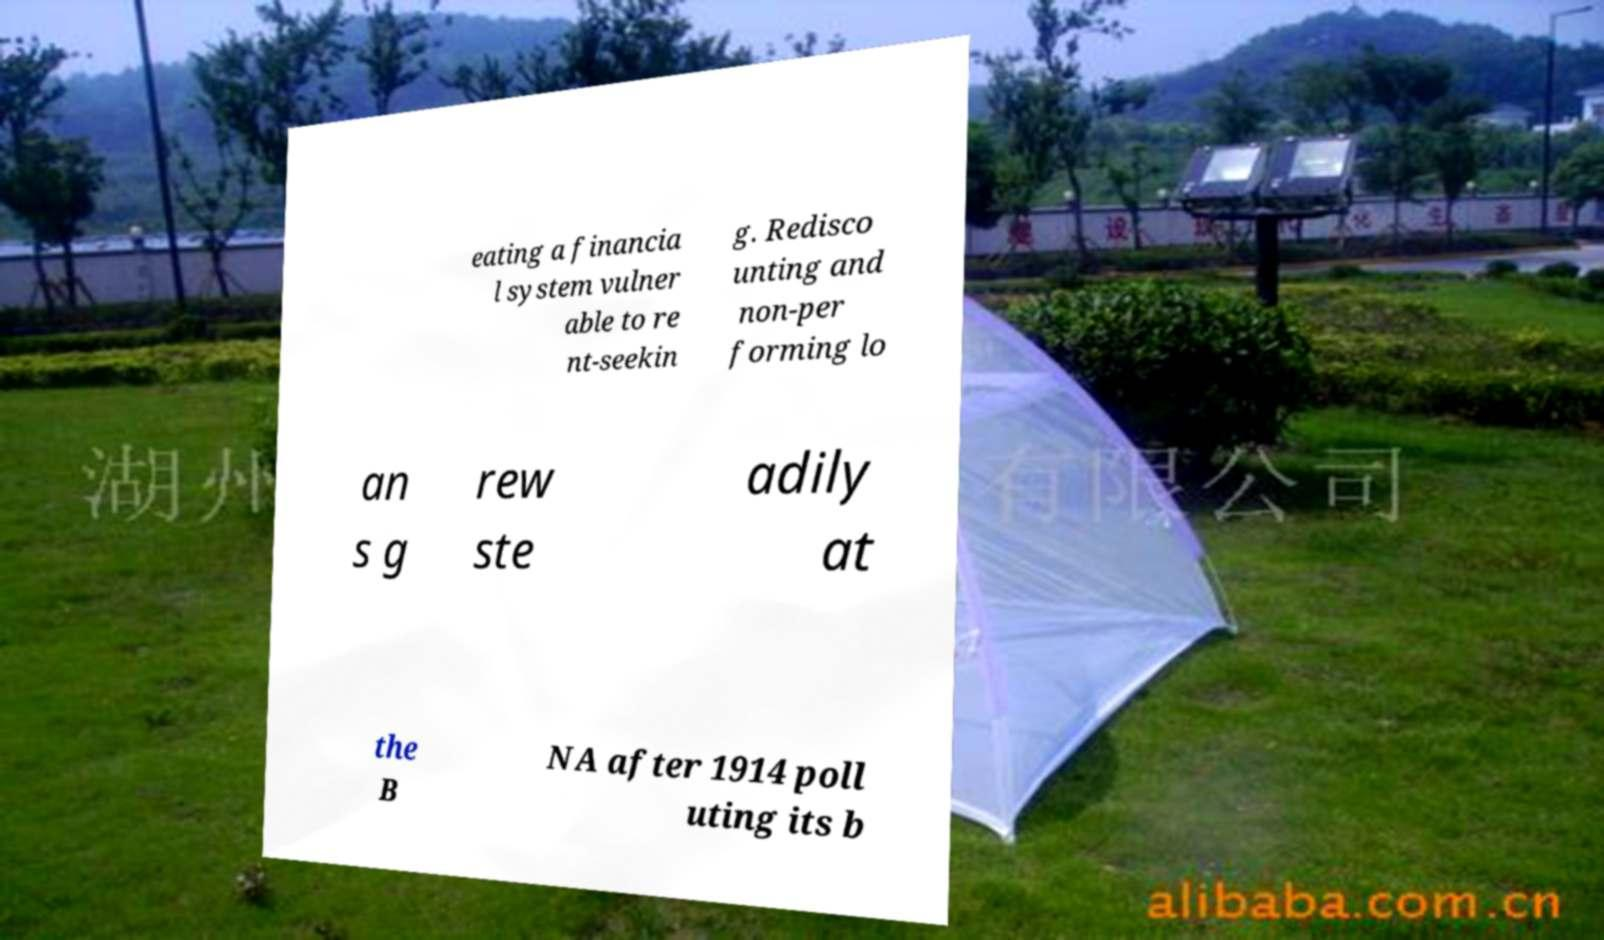What messages or text are displayed in this image? I need them in a readable, typed format. eating a financia l system vulner able to re nt-seekin g. Redisco unting and non-per forming lo an s g rew ste adily at the B NA after 1914 poll uting its b 